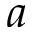Convert formula to latex. <formula><loc_0><loc_0><loc_500><loc_500>a</formula> 